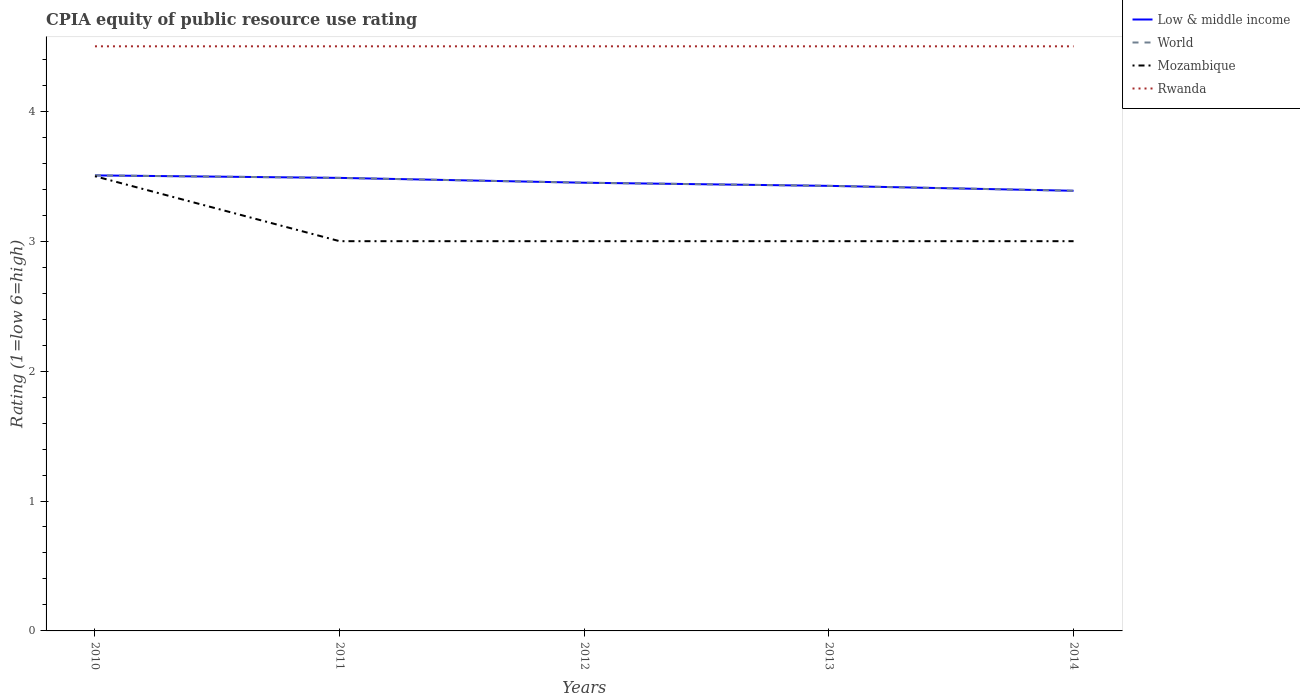How many different coloured lines are there?
Offer a very short reply. 4. Does the line corresponding to World intersect with the line corresponding to Rwanda?
Give a very brief answer. No. Is the number of lines equal to the number of legend labels?
Provide a short and direct response. Yes. Across all years, what is the maximum CPIA rating in Low & middle income?
Offer a very short reply. 3.39. In which year was the CPIA rating in Mozambique maximum?
Keep it short and to the point. 2011. What is the difference between the highest and the second highest CPIA rating in Rwanda?
Make the answer very short. 0. What is the difference between the highest and the lowest CPIA rating in Rwanda?
Ensure brevity in your answer.  0. How many years are there in the graph?
Your answer should be compact. 5. Are the values on the major ticks of Y-axis written in scientific E-notation?
Offer a terse response. No. Does the graph contain any zero values?
Your answer should be very brief. No. How many legend labels are there?
Your response must be concise. 4. What is the title of the graph?
Ensure brevity in your answer.  CPIA equity of public resource use rating. What is the label or title of the X-axis?
Give a very brief answer. Years. What is the Rating (1=low 6=high) of Low & middle income in 2010?
Make the answer very short. 3.51. What is the Rating (1=low 6=high) in World in 2010?
Your response must be concise. 3.51. What is the Rating (1=low 6=high) in Mozambique in 2010?
Ensure brevity in your answer.  3.5. What is the Rating (1=low 6=high) of Low & middle income in 2011?
Give a very brief answer. 3.49. What is the Rating (1=low 6=high) of World in 2011?
Keep it short and to the point. 3.49. What is the Rating (1=low 6=high) of Low & middle income in 2012?
Provide a succinct answer. 3.45. What is the Rating (1=low 6=high) in World in 2012?
Keep it short and to the point. 3.45. What is the Rating (1=low 6=high) of Mozambique in 2012?
Give a very brief answer. 3. What is the Rating (1=low 6=high) of Rwanda in 2012?
Offer a terse response. 4.5. What is the Rating (1=low 6=high) of Low & middle income in 2013?
Provide a succinct answer. 3.43. What is the Rating (1=low 6=high) in World in 2013?
Your response must be concise. 3.43. What is the Rating (1=low 6=high) of Mozambique in 2013?
Offer a very short reply. 3. What is the Rating (1=low 6=high) in Rwanda in 2013?
Provide a succinct answer. 4.5. What is the Rating (1=low 6=high) of Low & middle income in 2014?
Provide a succinct answer. 3.39. What is the Rating (1=low 6=high) in World in 2014?
Keep it short and to the point. 3.39. What is the Rating (1=low 6=high) in Mozambique in 2014?
Give a very brief answer. 3. What is the Rating (1=low 6=high) of Rwanda in 2014?
Keep it short and to the point. 4.5. Across all years, what is the maximum Rating (1=low 6=high) in Low & middle income?
Provide a short and direct response. 3.51. Across all years, what is the maximum Rating (1=low 6=high) in World?
Offer a very short reply. 3.51. Across all years, what is the minimum Rating (1=low 6=high) in Low & middle income?
Make the answer very short. 3.39. Across all years, what is the minimum Rating (1=low 6=high) of World?
Give a very brief answer. 3.39. Across all years, what is the minimum Rating (1=low 6=high) in Rwanda?
Your answer should be very brief. 4.5. What is the total Rating (1=low 6=high) in Low & middle income in the graph?
Provide a short and direct response. 17.26. What is the total Rating (1=low 6=high) in World in the graph?
Your response must be concise. 17.26. What is the total Rating (1=low 6=high) in Mozambique in the graph?
Your answer should be compact. 15.5. What is the total Rating (1=low 6=high) of Rwanda in the graph?
Your answer should be compact. 22.5. What is the difference between the Rating (1=low 6=high) in Low & middle income in 2010 and that in 2011?
Offer a terse response. 0.02. What is the difference between the Rating (1=low 6=high) of World in 2010 and that in 2011?
Provide a succinct answer. 0.02. What is the difference between the Rating (1=low 6=high) in Mozambique in 2010 and that in 2011?
Your answer should be very brief. 0.5. What is the difference between the Rating (1=low 6=high) in Rwanda in 2010 and that in 2011?
Keep it short and to the point. 0. What is the difference between the Rating (1=low 6=high) of Low & middle income in 2010 and that in 2012?
Make the answer very short. 0.06. What is the difference between the Rating (1=low 6=high) of World in 2010 and that in 2012?
Your response must be concise. 0.06. What is the difference between the Rating (1=low 6=high) in Rwanda in 2010 and that in 2012?
Ensure brevity in your answer.  0. What is the difference between the Rating (1=low 6=high) of Low & middle income in 2010 and that in 2013?
Your answer should be very brief. 0.08. What is the difference between the Rating (1=low 6=high) of World in 2010 and that in 2013?
Ensure brevity in your answer.  0.08. What is the difference between the Rating (1=low 6=high) in Mozambique in 2010 and that in 2013?
Provide a short and direct response. 0.5. What is the difference between the Rating (1=low 6=high) of Low & middle income in 2010 and that in 2014?
Make the answer very short. 0.12. What is the difference between the Rating (1=low 6=high) of World in 2010 and that in 2014?
Keep it short and to the point. 0.12. What is the difference between the Rating (1=low 6=high) of Low & middle income in 2011 and that in 2012?
Provide a succinct answer. 0.04. What is the difference between the Rating (1=low 6=high) in World in 2011 and that in 2012?
Make the answer very short. 0.04. What is the difference between the Rating (1=low 6=high) in Low & middle income in 2011 and that in 2013?
Your answer should be compact. 0.06. What is the difference between the Rating (1=low 6=high) in World in 2011 and that in 2013?
Make the answer very short. 0.06. What is the difference between the Rating (1=low 6=high) in Mozambique in 2011 and that in 2013?
Give a very brief answer. 0. What is the difference between the Rating (1=low 6=high) of Low & middle income in 2011 and that in 2014?
Give a very brief answer. 0.1. What is the difference between the Rating (1=low 6=high) of World in 2011 and that in 2014?
Keep it short and to the point. 0.1. What is the difference between the Rating (1=low 6=high) in Mozambique in 2011 and that in 2014?
Offer a terse response. 0. What is the difference between the Rating (1=low 6=high) of Rwanda in 2011 and that in 2014?
Ensure brevity in your answer.  0. What is the difference between the Rating (1=low 6=high) in Low & middle income in 2012 and that in 2013?
Make the answer very short. 0.02. What is the difference between the Rating (1=low 6=high) in World in 2012 and that in 2013?
Offer a terse response. 0.02. What is the difference between the Rating (1=low 6=high) in Mozambique in 2012 and that in 2013?
Keep it short and to the point. 0. What is the difference between the Rating (1=low 6=high) of Low & middle income in 2012 and that in 2014?
Your response must be concise. 0.06. What is the difference between the Rating (1=low 6=high) of World in 2012 and that in 2014?
Keep it short and to the point. 0.06. What is the difference between the Rating (1=low 6=high) in Rwanda in 2012 and that in 2014?
Your answer should be very brief. 0. What is the difference between the Rating (1=low 6=high) of Low & middle income in 2013 and that in 2014?
Offer a very short reply. 0.04. What is the difference between the Rating (1=low 6=high) of World in 2013 and that in 2014?
Ensure brevity in your answer.  0.04. What is the difference between the Rating (1=low 6=high) in Mozambique in 2013 and that in 2014?
Offer a very short reply. 0. What is the difference between the Rating (1=low 6=high) of Low & middle income in 2010 and the Rating (1=low 6=high) of World in 2011?
Your answer should be very brief. 0.02. What is the difference between the Rating (1=low 6=high) of Low & middle income in 2010 and the Rating (1=low 6=high) of Mozambique in 2011?
Your answer should be very brief. 0.51. What is the difference between the Rating (1=low 6=high) of Low & middle income in 2010 and the Rating (1=low 6=high) of Rwanda in 2011?
Offer a very short reply. -0.99. What is the difference between the Rating (1=low 6=high) of World in 2010 and the Rating (1=low 6=high) of Mozambique in 2011?
Keep it short and to the point. 0.51. What is the difference between the Rating (1=low 6=high) in World in 2010 and the Rating (1=low 6=high) in Rwanda in 2011?
Your answer should be compact. -0.99. What is the difference between the Rating (1=low 6=high) in Low & middle income in 2010 and the Rating (1=low 6=high) in World in 2012?
Your answer should be very brief. 0.06. What is the difference between the Rating (1=low 6=high) in Low & middle income in 2010 and the Rating (1=low 6=high) in Mozambique in 2012?
Make the answer very short. 0.51. What is the difference between the Rating (1=low 6=high) of Low & middle income in 2010 and the Rating (1=low 6=high) of Rwanda in 2012?
Ensure brevity in your answer.  -0.99. What is the difference between the Rating (1=low 6=high) in World in 2010 and the Rating (1=low 6=high) in Mozambique in 2012?
Offer a terse response. 0.51. What is the difference between the Rating (1=low 6=high) in World in 2010 and the Rating (1=low 6=high) in Rwanda in 2012?
Ensure brevity in your answer.  -0.99. What is the difference between the Rating (1=low 6=high) of Mozambique in 2010 and the Rating (1=low 6=high) of Rwanda in 2012?
Provide a succinct answer. -1. What is the difference between the Rating (1=low 6=high) in Low & middle income in 2010 and the Rating (1=low 6=high) in World in 2013?
Provide a succinct answer. 0.08. What is the difference between the Rating (1=low 6=high) in Low & middle income in 2010 and the Rating (1=low 6=high) in Mozambique in 2013?
Your response must be concise. 0.51. What is the difference between the Rating (1=low 6=high) in Low & middle income in 2010 and the Rating (1=low 6=high) in Rwanda in 2013?
Ensure brevity in your answer.  -0.99. What is the difference between the Rating (1=low 6=high) in World in 2010 and the Rating (1=low 6=high) in Mozambique in 2013?
Offer a very short reply. 0.51. What is the difference between the Rating (1=low 6=high) in World in 2010 and the Rating (1=low 6=high) in Rwanda in 2013?
Provide a succinct answer. -0.99. What is the difference between the Rating (1=low 6=high) in Mozambique in 2010 and the Rating (1=low 6=high) in Rwanda in 2013?
Your answer should be very brief. -1. What is the difference between the Rating (1=low 6=high) of Low & middle income in 2010 and the Rating (1=low 6=high) of World in 2014?
Offer a terse response. 0.12. What is the difference between the Rating (1=low 6=high) of Low & middle income in 2010 and the Rating (1=low 6=high) of Mozambique in 2014?
Provide a succinct answer. 0.51. What is the difference between the Rating (1=low 6=high) in Low & middle income in 2010 and the Rating (1=low 6=high) in Rwanda in 2014?
Your answer should be compact. -0.99. What is the difference between the Rating (1=low 6=high) in World in 2010 and the Rating (1=low 6=high) in Mozambique in 2014?
Your answer should be compact. 0.51. What is the difference between the Rating (1=low 6=high) of World in 2010 and the Rating (1=low 6=high) of Rwanda in 2014?
Offer a terse response. -0.99. What is the difference between the Rating (1=low 6=high) of Low & middle income in 2011 and the Rating (1=low 6=high) of World in 2012?
Ensure brevity in your answer.  0.04. What is the difference between the Rating (1=low 6=high) in Low & middle income in 2011 and the Rating (1=low 6=high) in Mozambique in 2012?
Provide a short and direct response. 0.49. What is the difference between the Rating (1=low 6=high) of Low & middle income in 2011 and the Rating (1=low 6=high) of Rwanda in 2012?
Your response must be concise. -1.01. What is the difference between the Rating (1=low 6=high) of World in 2011 and the Rating (1=low 6=high) of Mozambique in 2012?
Provide a short and direct response. 0.49. What is the difference between the Rating (1=low 6=high) in World in 2011 and the Rating (1=low 6=high) in Rwanda in 2012?
Your answer should be very brief. -1.01. What is the difference between the Rating (1=low 6=high) of Low & middle income in 2011 and the Rating (1=low 6=high) of World in 2013?
Your answer should be compact. 0.06. What is the difference between the Rating (1=low 6=high) in Low & middle income in 2011 and the Rating (1=low 6=high) in Mozambique in 2013?
Ensure brevity in your answer.  0.49. What is the difference between the Rating (1=low 6=high) of Low & middle income in 2011 and the Rating (1=low 6=high) of Rwanda in 2013?
Offer a very short reply. -1.01. What is the difference between the Rating (1=low 6=high) of World in 2011 and the Rating (1=low 6=high) of Mozambique in 2013?
Offer a terse response. 0.49. What is the difference between the Rating (1=low 6=high) of World in 2011 and the Rating (1=low 6=high) of Rwanda in 2013?
Give a very brief answer. -1.01. What is the difference between the Rating (1=low 6=high) of Mozambique in 2011 and the Rating (1=low 6=high) of Rwanda in 2013?
Make the answer very short. -1.5. What is the difference between the Rating (1=low 6=high) of Low & middle income in 2011 and the Rating (1=low 6=high) of World in 2014?
Make the answer very short. 0.1. What is the difference between the Rating (1=low 6=high) in Low & middle income in 2011 and the Rating (1=low 6=high) in Mozambique in 2014?
Make the answer very short. 0.49. What is the difference between the Rating (1=low 6=high) of Low & middle income in 2011 and the Rating (1=low 6=high) of Rwanda in 2014?
Make the answer very short. -1.01. What is the difference between the Rating (1=low 6=high) of World in 2011 and the Rating (1=low 6=high) of Mozambique in 2014?
Ensure brevity in your answer.  0.49. What is the difference between the Rating (1=low 6=high) of World in 2011 and the Rating (1=low 6=high) of Rwanda in 2014?
Keep it short and to the point. -1.01. What is the difference between the Rating (1=low 6=high) of Low & middle income in 2012 and the Rating (1=low 6=high) of World in 2013?
Your response must be concise. 0.02. What is the difference between the Rating (1=low 6=high) in Low & middle income in 2012 and the Rating (1=low 6=high) in Mozambique in 2013?
Offer a very short reply. 0.45. What is the difference between the Rating (1=low 6=high) in Low & middle income in 2012 and the Rating (1=low 6=high) in Rwanda in 2013?
Provide a short and direct response. -1.05. What is the difference between the Rating (1=low 6=high) of World in 2012 and the Rating (1=low 6=high) of Mozambique in 2013?
Your answer should be compact. 0.45. What is the difference between the Rating (1=low 6=high) in World in 2012 and the Rating (1=low 6=high) in Rwanda in 2013?
Keep it short and to the point. -1.05. What is the difference between the Rating (1=low 6=high) in Low & middle income in 2012 and the Rating (1=low 6=high) in World in 2014?
Offer a very short reply. 0.06. What is the difference between the Rating (1=low 6=high) in Low & middle income in 2012 and the Rating (1=low 6=high) in Mozambique in 2014?
Make the answer very short. 0.45. What is the difference between the Rating (1=low 6=high) of Low & middle income in 2012 and the Rating (1=low 6=high) of Rwanda in 2014?
Your answer should be very brief. -1.05. What is the difference between the Rating (1=low 6=high) of World in 2012 and the Rating (1=low 6=high) of Mozambique in 2014?
Your response must be concise. 0.45. What is the difference between the Rating (1=low 6=high) of World in 2012 and the Rating (1=low 6=high) of Rwanda in 2014?
Your answer should be very brief. -1.05. What is the difference between the Rating (1=low 6=high) of Low & middle income in 2013 and the Rating (1=low 6=high) of World in 2014?
Keep it short and to the point. 0.04. What is the difference between the Rating (1=low 6=high) in Low & middle income in 2013 and the Rating (1=low 6=high) in Mozambique in 2014?
Your answer should be compact. 0.43. What is the difference between the Rating (1=low 6=high) of Low & middle income in 2013 and the Rating (1=low 6=high) of Rwanda in 2014?
Keep it short and to the point. -1.07. What is the difference between the Rating (1=low 6=high) of World in 2013 and the Rating (1=low 6=high) of Mozambique in 2014?
Provide a succinct answer. 0.43. What is the difference between the Rating (1=low 6=high) of World in 2013 and the Rating (1=low 6=high) of Rwanda in 2014?
Keep it short and to the point. -1.07. What is the average Rating (1=low 6=high) of Low & middle income per year?
Provide a short and direct response. 3.45. What is the average Rating (1=low 6=high) of World per year?
Offer a very short reply. 3.45. What is the average Rating (1=low 6=high) of Mozambique per year?
Keep it short and to the point. 3.1. What is the average Rating (1=low 6=high) of Rwanda per year?
Keep it short and to the point. 4.5. In the year 2010, what is the difference between the Rating (1=low 6=high) in Low & middle income and Rating (1=low 6=high) in Mozambique?
Make the answer very short. 0.01. In the year 2010, what is the difference between the Rating (1=low 6=high) in Low & middle income and Rating (1=low 6=high) in Rwanda?
Offer a very short reply. -0.99. In the year 2010, what is the difference between the Rating (1=low 6=high) of World and Rating (1=low 6=high) of Mozambique?
Give a very brief answer. 0.01. In the year 2010, what is the difference between the Rating (1=low 6=high) of World and Rating (1=low 6=high) of Rwanda?
Give a very brief answer. -0.99. In the year 2011, what is the difference between the Rating (1=low 6=high) of Low & middle income and Rating (1=low 6=high) of Mozambique?
Give a very brief answer. 0.49. In the year 2011, what is the difference between the Rating (1=low 6=high) of Low & middle income and Rating (1=low 6=high) of Rwanda?
Provide a short and direct response. -1.01. In the year 2011, what is the difference between the Rating (1=low 6=high) in World and Rating (1=low 6=high) in Mozambique?
Your answer should be compact. 0.49. In the year 2011, what is the difference between the Rating (1=low 6=high) in World and Rating (1=low 6=high) in Rwanda?
Provide a short and direct response. -1.01. In the year 2012, what is the difference between the Rating (1=low 6=high) of Low & middle income and Rating (1=low 6=high) of Mozambique?
Ensure brevity in your answer.  0.45. In the year 2012, what is the difference between the Rating (1=low 6=high) in Low & middle income and Rating (1=low 6=high) in Rwanda?
Offer a very short reply. -1.05. In the year 2012, what is the difference between the Rating (1=low 6=high) in World and Rating (1=low 6=high) in Mozambique?
Offer a terse response. 0.45. In the year 2012, what is the difference between the Rating (1=low 6=high) of World and Rating (1=low 6=high) of Rwanda?
Your answer should be compact. -1.05. In the year 2012, what is the difference between the Rating (1=low 6=high) in Mozambique and Rating (1=low 6=high) in Rwanda?
Provide a succinct answer. -1.5. In the year 2013, what is the difference between the Rating (1=low 6=high) of Low & middle income and Rating (1=low 6=high) of Mozambique?
Keep it short and to the point. 0.43. In the year 2013, what is the difference between the Rating (1=low 6=high) in Low & middle income and Rating (1=low 6=high) in Rwanda?
Provide a succinct answer. -1.07. In the year 2013, what is the difference between the Rating (1=low 6=high) of World and Rating (1=low 6=high) of Mozambique?
Provide a short and direct response. 0.43. In the year 2013, what is the difference between the Rating (1=low 6=high) in World and Rating (1=low 6=high) in Rwanda?
Your answer should be compact. -1.07. In the year 2014, what is the difference between the Rating (1=low 6=high) in Low & middle income and Rating (1=low 6=high) in Mozambique?
Ensure brevity in your answer.  0.39. In the year 2014, what is the difference between the Rating (1=low 6=high) of Low & middle income and Rating (1=low 6=high) of Rwanda?
Offer a very short reply. -1.11. In the year 2014, what is the difference between the Rating (1=low 6=high) in World and Rating (1=low 6=high) in Mozambique?
Provide a short and direct response. 0.39. In the year 2014, what is the difference between the Rating (1=low 6=high) in World and Rating (1=low 6=high) in Rwanda?
Offer a terse response. -1.11. In the year 2014, what is the difference between the Rating (1=low 6=high) in Mozambique and Rating (1=low 6=high) in Rwanda?
Offer a very short reply. -1.5. What is the ratio of the Rating (1=low 6=high) of Mozambique in 2010 to that in 2011?
Offer a terse response. 1.17. What is the ratio of the Rating (1=low 6=high) of Low & middle income in 2010 to that in 2012?
Your answer should be very brief. 1.02. What is the ratio of the Rating (1=low 6=high) in World in 2010 to that in 2012?
Keep it short and to the point. 1.02. What is the ratio of the Rating (1=low 6=high) of Low & middle income in 2010 to that in 2013?
Provide a short and direct response. 1.02. What is the ratio of the Rating (1=low 6=high) in World in 2010 to that in 2013?
Your answer should be very brief. 1.02. What is the ratio of the Rating (1=low 6=high) of Rwanda in 2010 to that in 2013?
Offer a terse response. 1. What is the ratio of the Rating (1=low 6=high) in Low & middle income in 2010 to that in 2014?
Give a very brief answer. 1.03. What is the ratio of the Rating (1=low 6=high) in World in 2010 to that in 2014?
Give a very brief answer. 1.03. What is the ratio of the Rating (1=low 6=high) in Mozambique in 2010 to that in 2014?
Provide a short and direct response. 1.17. What is the ratio of the Rating (1=low 6=high) of Low & middle income in 2011 to that in 2012?
Provide a short and direct response. 1.01. What is the ratio of the Rating (1=low 6=high) in World in 2011 to that in 2012?
Your answer should be very brief. 1.01. What is the ratio of the Rating (1=low 6=high) in Mozambique in 2011 to that in 2012?
Give a very brief answer. 1. What is the ratio of the Rating (1=low 6=high) of Rwanda in 2011 to that in 2012?
Make the answer very short. 1. What is the ratio of the Rating (1=low 6=high) in Low & middle income in 2011 to that in 2013?
Offer a very short reply. 1.02. What is the ratio of the Rating (1=low 6=high) in World in 2011 to that in 2013?
Your answer should be very brief. 1.02. What is the ratio of the Rating (1=low 6=high) in Mozambique in 2011 to that in 2013?
Ensure brevity in your answer.  1. What is the ratio of the Rating (1=low 6=high) of Low & middle income in 2011 to that in 2014?
Make the answer very short. 1.03. What is the ratio of the Rating (1=low 6=high) of World in 2011 to that in 2014?
Ensure brevity in your answer.  1.03. What is the ratio of the Rating (1=low 6=high) of Rwanda in 2012 to that in 2013?
Keep it short and to the point. 1. What is the ratio of the Rating (1=low 6=high) in Low & middle income in 2012 to that in 2014?
Keep it short and to the point. 1.02. What is the ratio of the Rating (1=low 6=high) in World in 2012 to that in 2014?
Your answer should be compact. 1.02. What is the ratio of the Rating (1=low 6=high) of Mozambique in 2012 to that in 2014?
Your response must be concise. 1. What is the ratio of the Rating (1=low 6=high) of Low & middle income in 2013 to that in 2014?
Provide a succinct answer. 1.01. What is the ratio of the Rating (1=low 6=high) of World in 2013 to that in 2014?
Keep it short and to the point. 1.01. What is the ratio of the Rating (1=low 6=high) in Mozambique in 2013 to that in 2014?
Make the answer very short. 1. What is the ratio of the Rating (1=low 6=high) of Rwanda in 2013 to that in 2014?
Make the answer very short. 1. What is the difference between the highest and the second highest Rating (1=low 6=high) in Low & middle income?
Give a very brief answer. 0.02. What is the difference between the highest and the second highest Rating (1=low 6=high) of World?
Offer a terse response. 0.02. What is the difference between the highest and the second highest Rating (1=low 6=high) in Mozambique?
Provide a short and direct response. 0.5. What is the difference between the highest and the second highest Rating (1=low 6=high) in Rwanda?
Provide a succinct answer. 0. What is the difference between the highest and the lowest Rating (1=low 6=high) of Low & middle income?
Your answer should be very brief. 0.12. What is the difference between the highest and the lowest Rating (1=low 6=high) of World?
Keep it short and to the point. 0.12. 